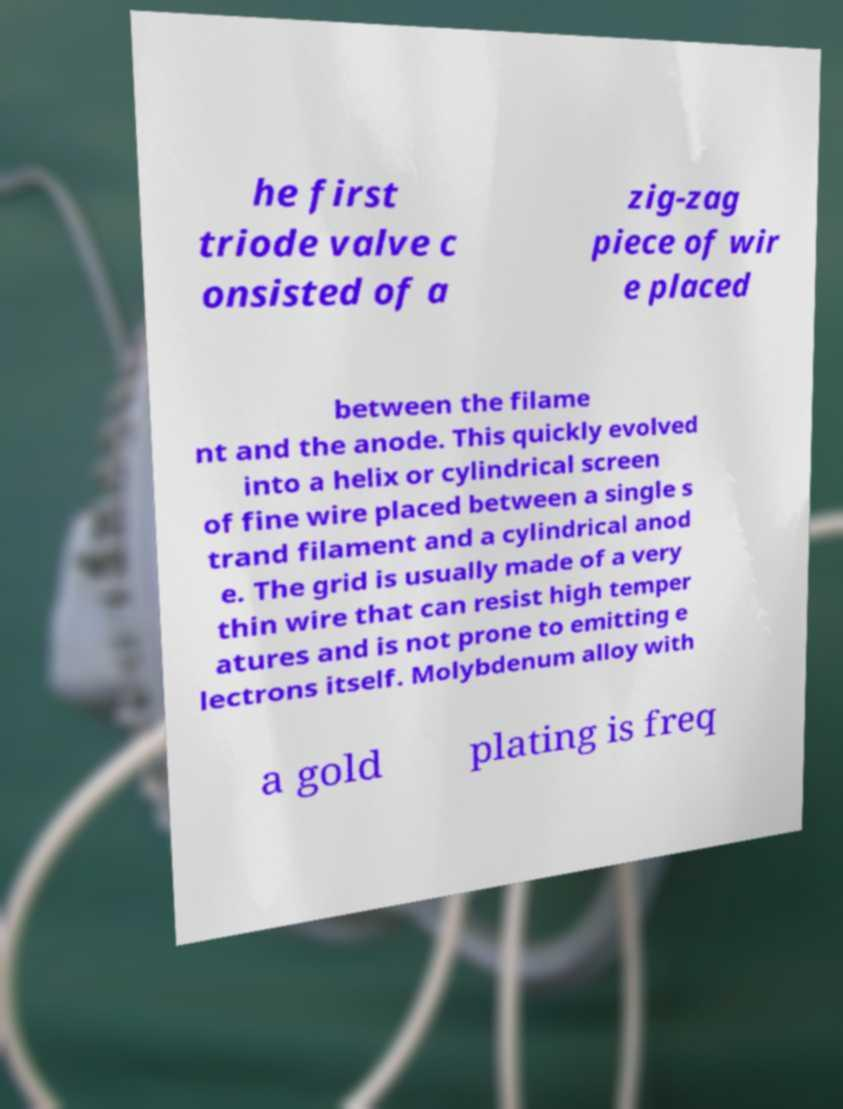Could you assist in decoding the text presented in this image and type it out clearly? he first triode valve c onsisted of a zig-zag piece of wir e placed between the filame nt and the anode. This quickly evolved into a helix or cylindrical screen of fine wire placed between a single s trand filament and a cylindrical anod e. The grid is usually made of a very thin wire that can resist high temper atures and is not prone to emitting e lectrons itself. Molybdenum alloy with a gold plating is freq 